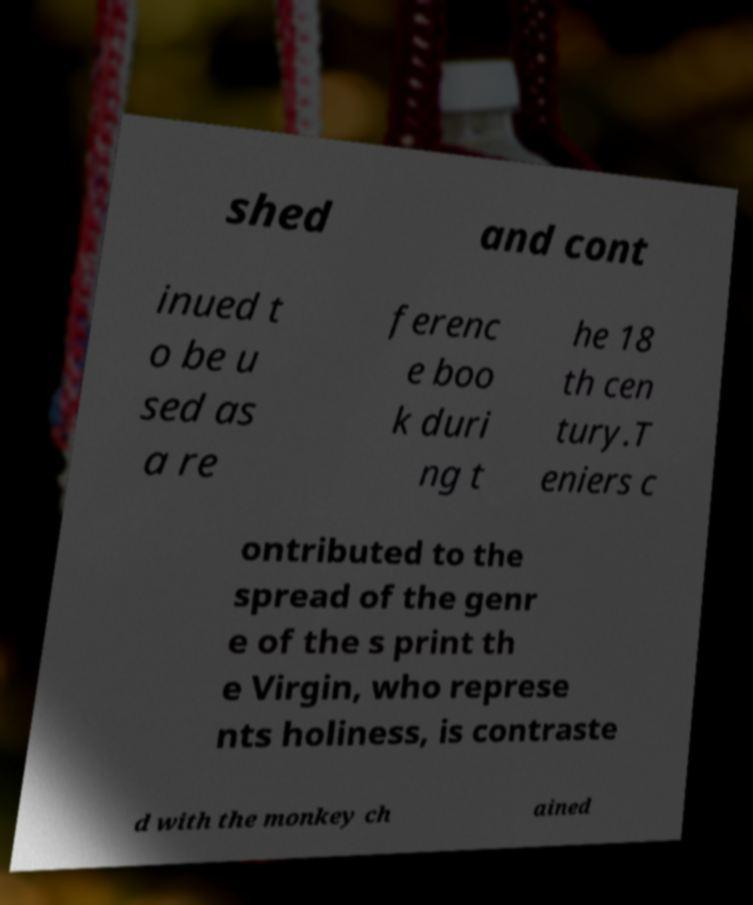Could you extract and type out the text from this image? shed and cont inued t o be u sed as a re ferenc e boo k duri ng t he 18 th cen tury.T eniers c ontributed to the spread of the genr e of the s print th e Virgin, who represe nts holiness, is contraste d with the monkey ch ained 